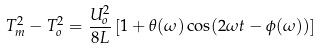<formula> <loc_0><loc_0><loc_500><loc_500>T _ { m } ^ { 2 } - T _ { o } ^ { 2 } = \frac { U _ { o } ^ { 2 } } { 8 L } \left [ 1 + \theta ( \omega ) \cos ( 2 \omega t - \phi ( \omega ) ) \right ]</formula> 